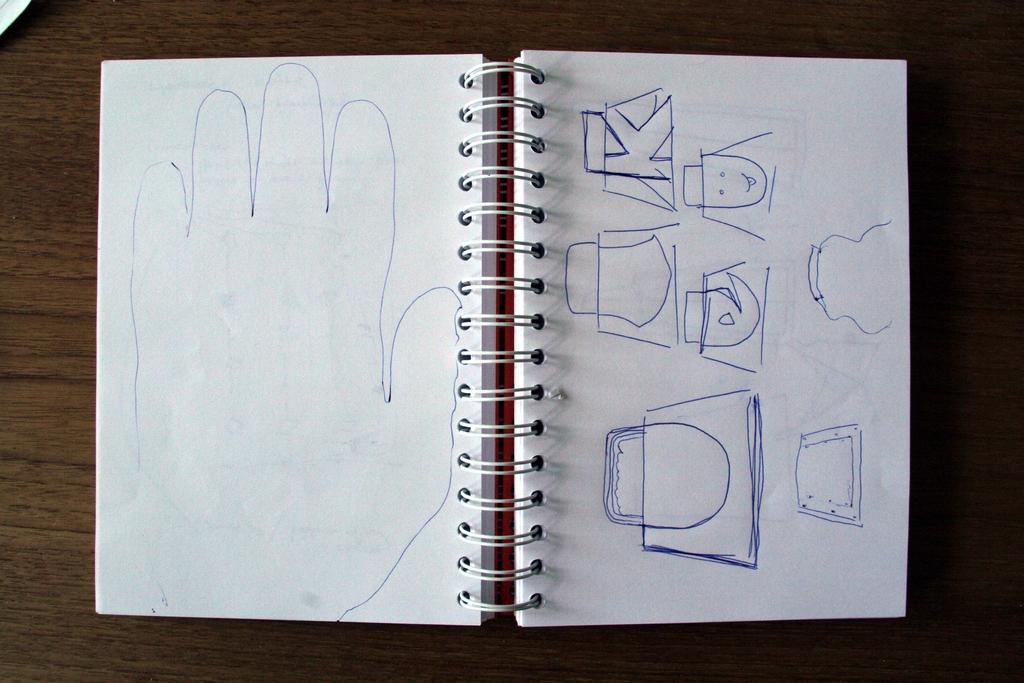In one or two sentences, can you explain what this image depicts? In the image on the wooden surface there is a spiral book. On the papers there are few images drawn on it. 